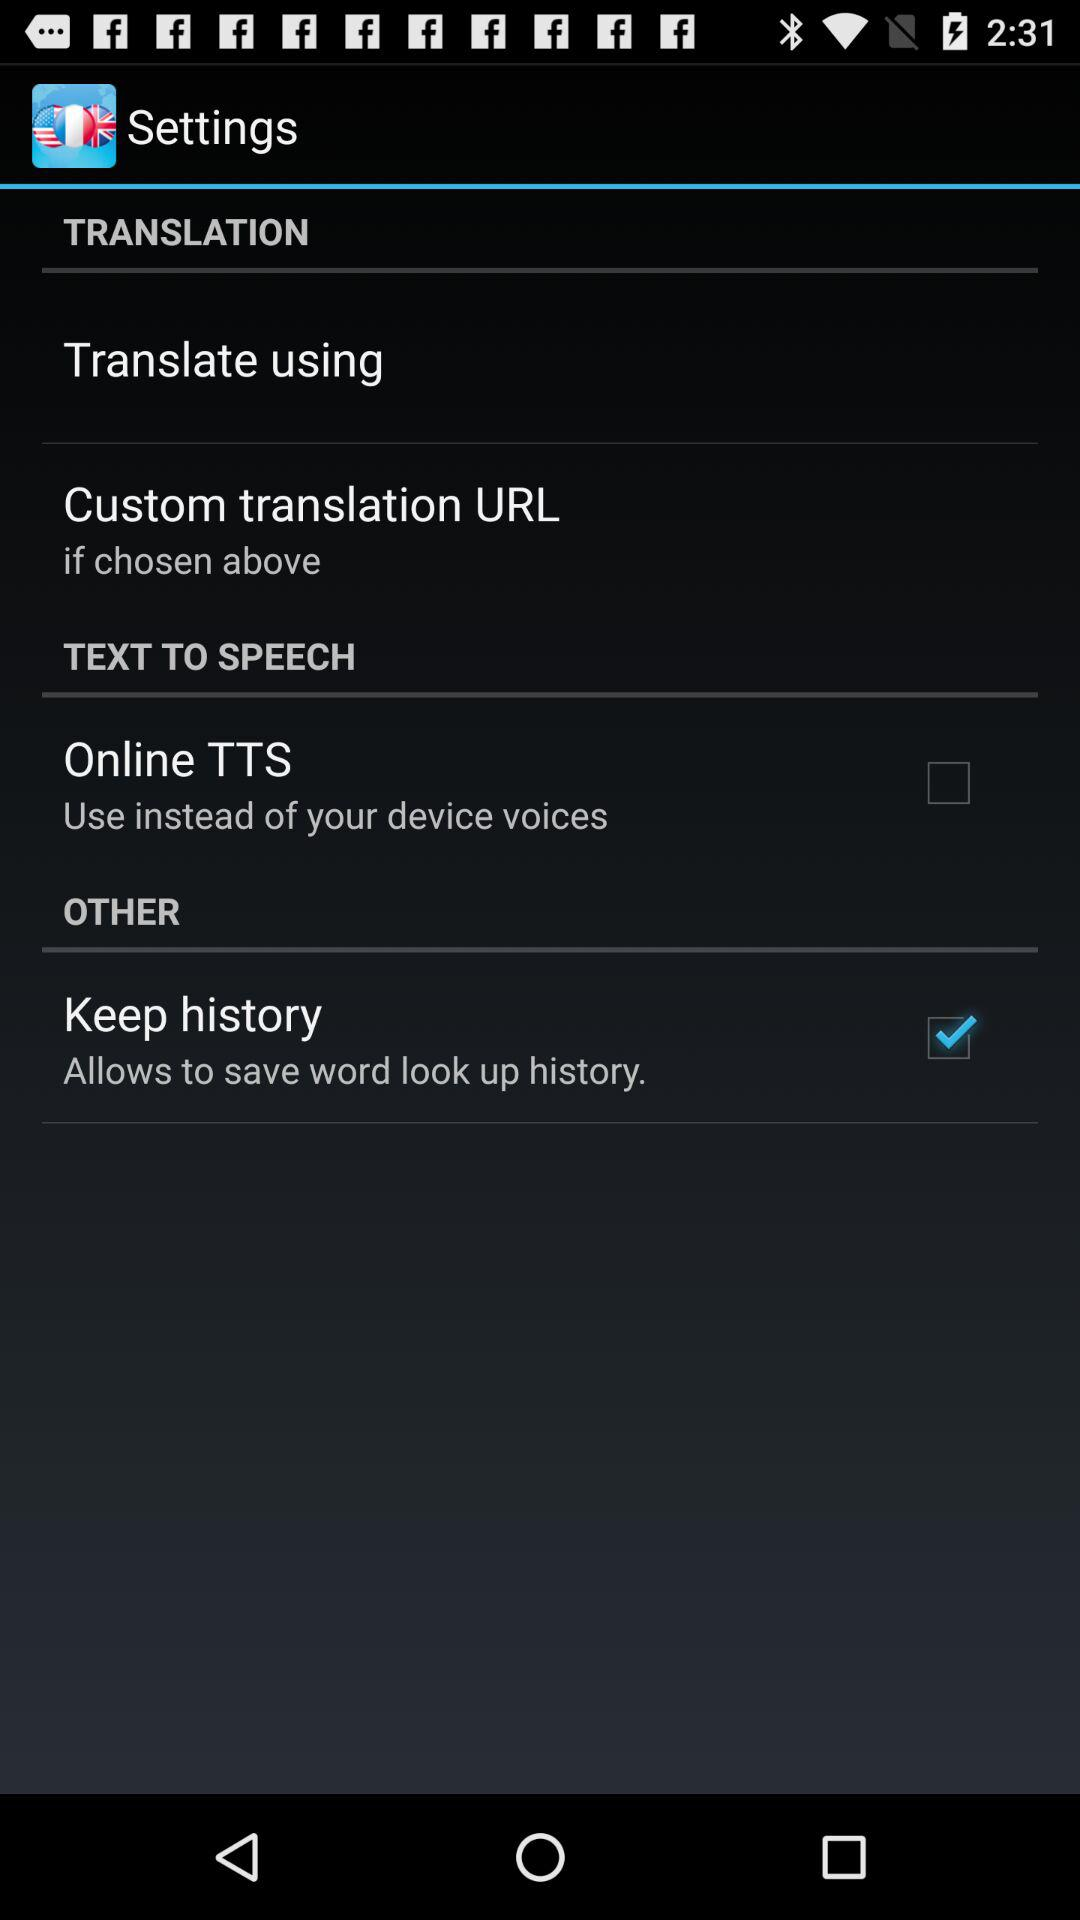What is the disabled setting? The disabled setting is "Online TTS". 